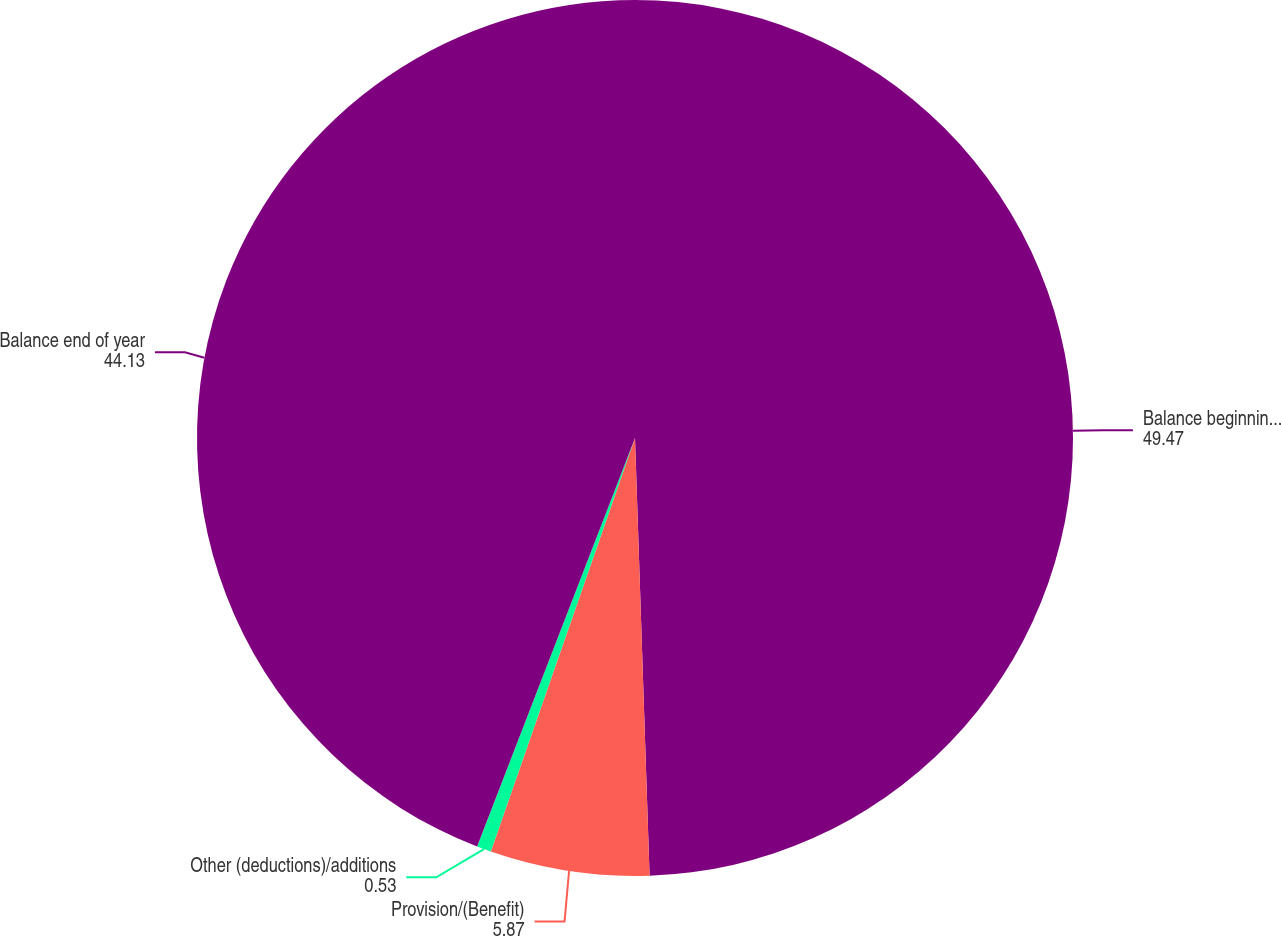Convert chart. <chart><loc_0><loc_0><loc_500><loc_500><pie_chart><fcel>Balance beginning of year<fcel>Provision/(Benefit)<fcel>Other (deductions)/additions<fcel>Balance end of year<nl><fcel>49.47%<fcel>5.87%<fcel>0.53%<fcel>44.13%<nl></chart> 